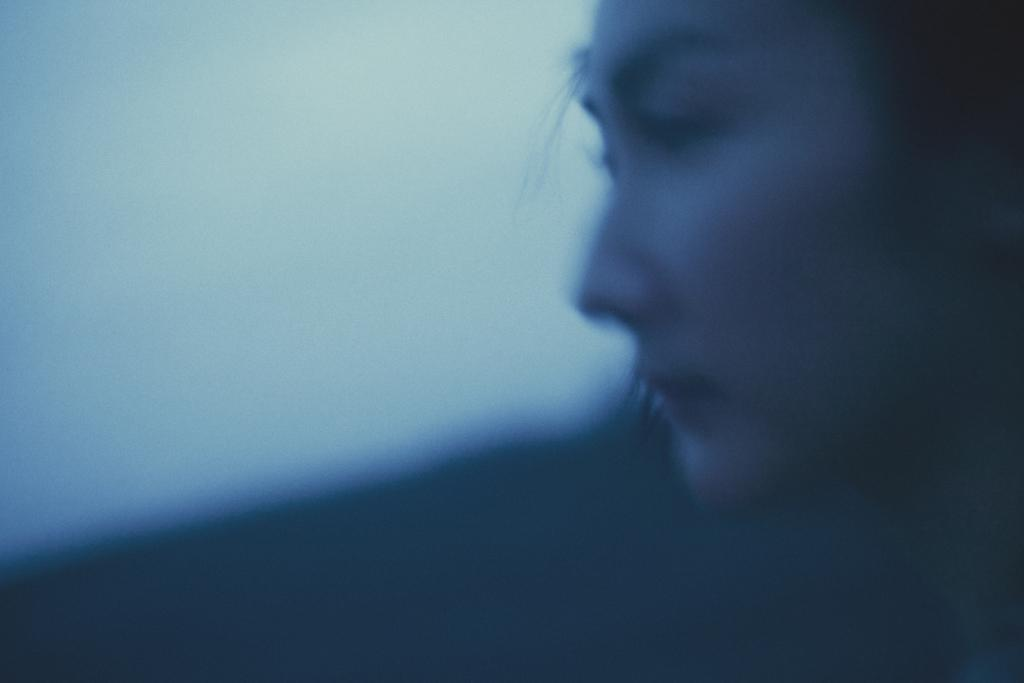Who is the main subject in the image? There is a girl in the image. Where is the girl located in the image? The girl is on the right side of the image. What type of squirrel can be seen interacting with the girl in the image? There is no squirrel present in the image; it only features a girl. What is the coefficient of friction between the girl and the surface she is standing on? The image does not provide enough information to determine the coefficient of friction between the girl and the surface she is standing on. 